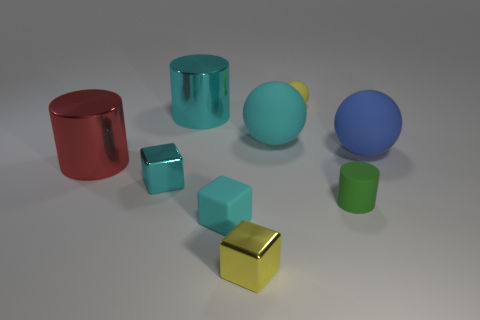Subtract all metallic cubes. How many cubes are left? 1 Subtract all green cylinders. How many cyan blocks are left? 2 Add 1 tiny cyan rubber cylinders. How many objects exist? 10 Subtract all cylinders. How many objects are left? 6 Subtract 1 cylinders. How many cylinders are left? 2 Add 8 yellow cylinders. How many yellow cylinders exist? 8 Subtract 1 red cylinders. How many objects are left? 8 Subtract all gray blocks. Subtract all red spheres. How many blocks are left? 3 Subtract all yellow matte spheres. Subtract all yellow blocks. How many objects are left? 7 Add 5 green cylinders. How many green cylinders are left? 6 